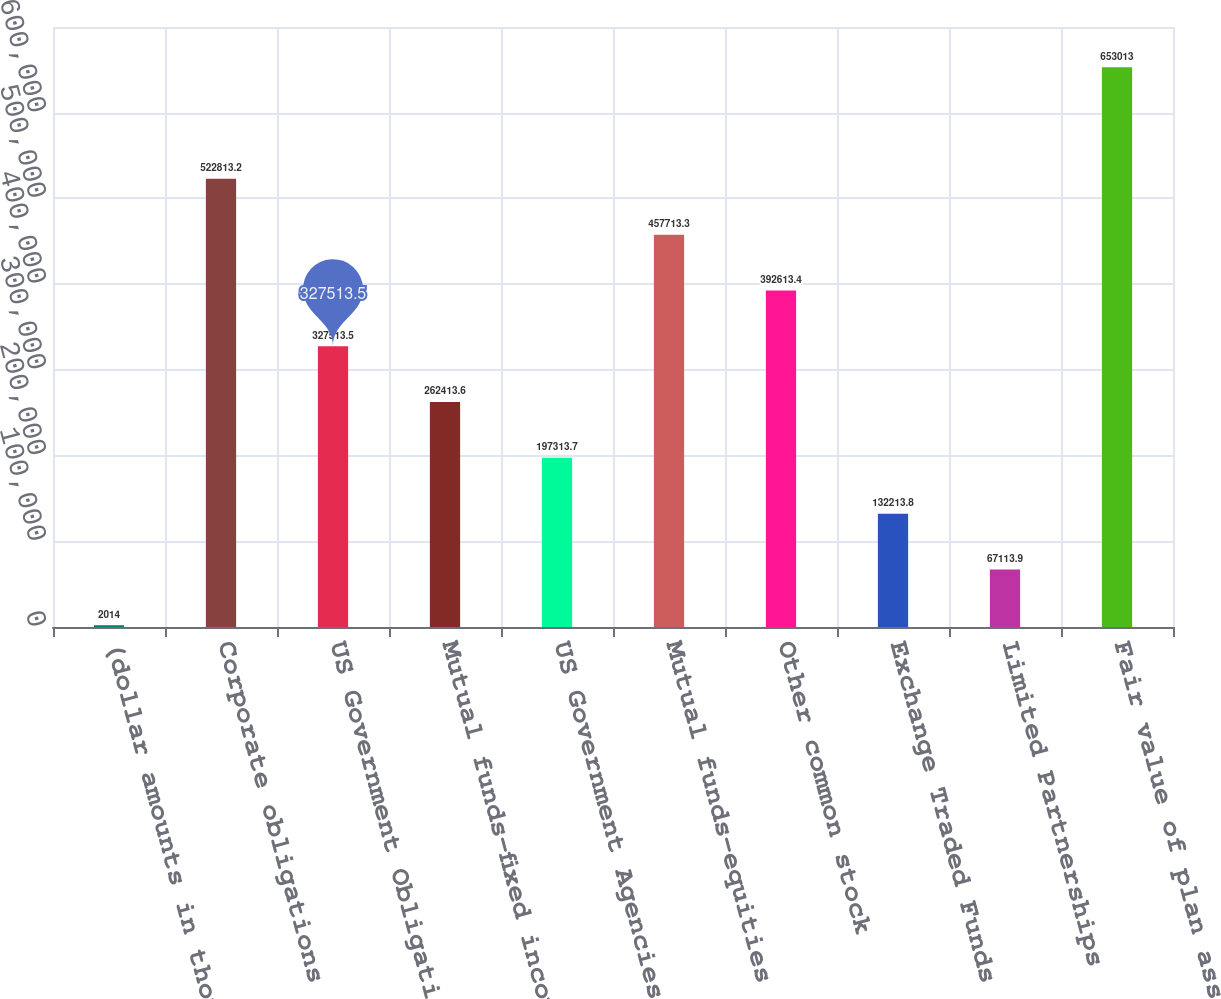Convert chart. <chart><loc_0><loc_0><loc_500><loc_500><bar_chart><fcel>(dollar amounts in thousands)<fcel>Corporate obligations<fcel>US Government Obligations<fcel>Mutual funds-fixed income<fcel>US Government Agencies<fcel>Mutual funds-equities<fcel>Other common stock<fcel>Exchange Traded Funds<fcel>Limited Partnerships<fcel>Fair value of plan assets<nl><fcel>2014<fcel>522813<fcel>327514<fcel>262414<fcel>197314<fcel>457713<fcel>392613<fcel>132214<fcel>67113.9<fcel>653013<nl></chart> 